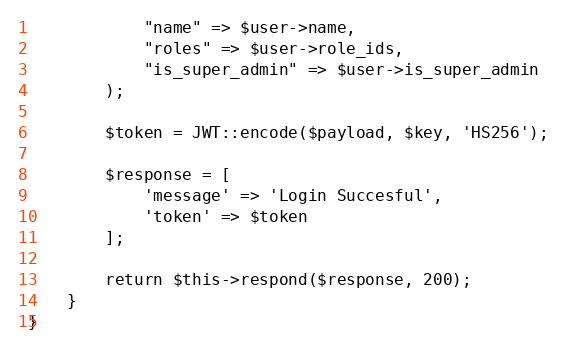Convert code to text. <code><loc_0><loc_0><loc_500><loc_500><_PHP_>            "name" => $user->name,
            "roles" => $user->role_ids,
            "is_super_admin" => $user->is_super_admin
        );

        $token = JWT::encode($payload, $key, 'HS256');

        $response = [
            'message' => 'Login Succesful',
            'token' => $token
        ];

        return $this->respond($response, 200);
    }
}
</code> 